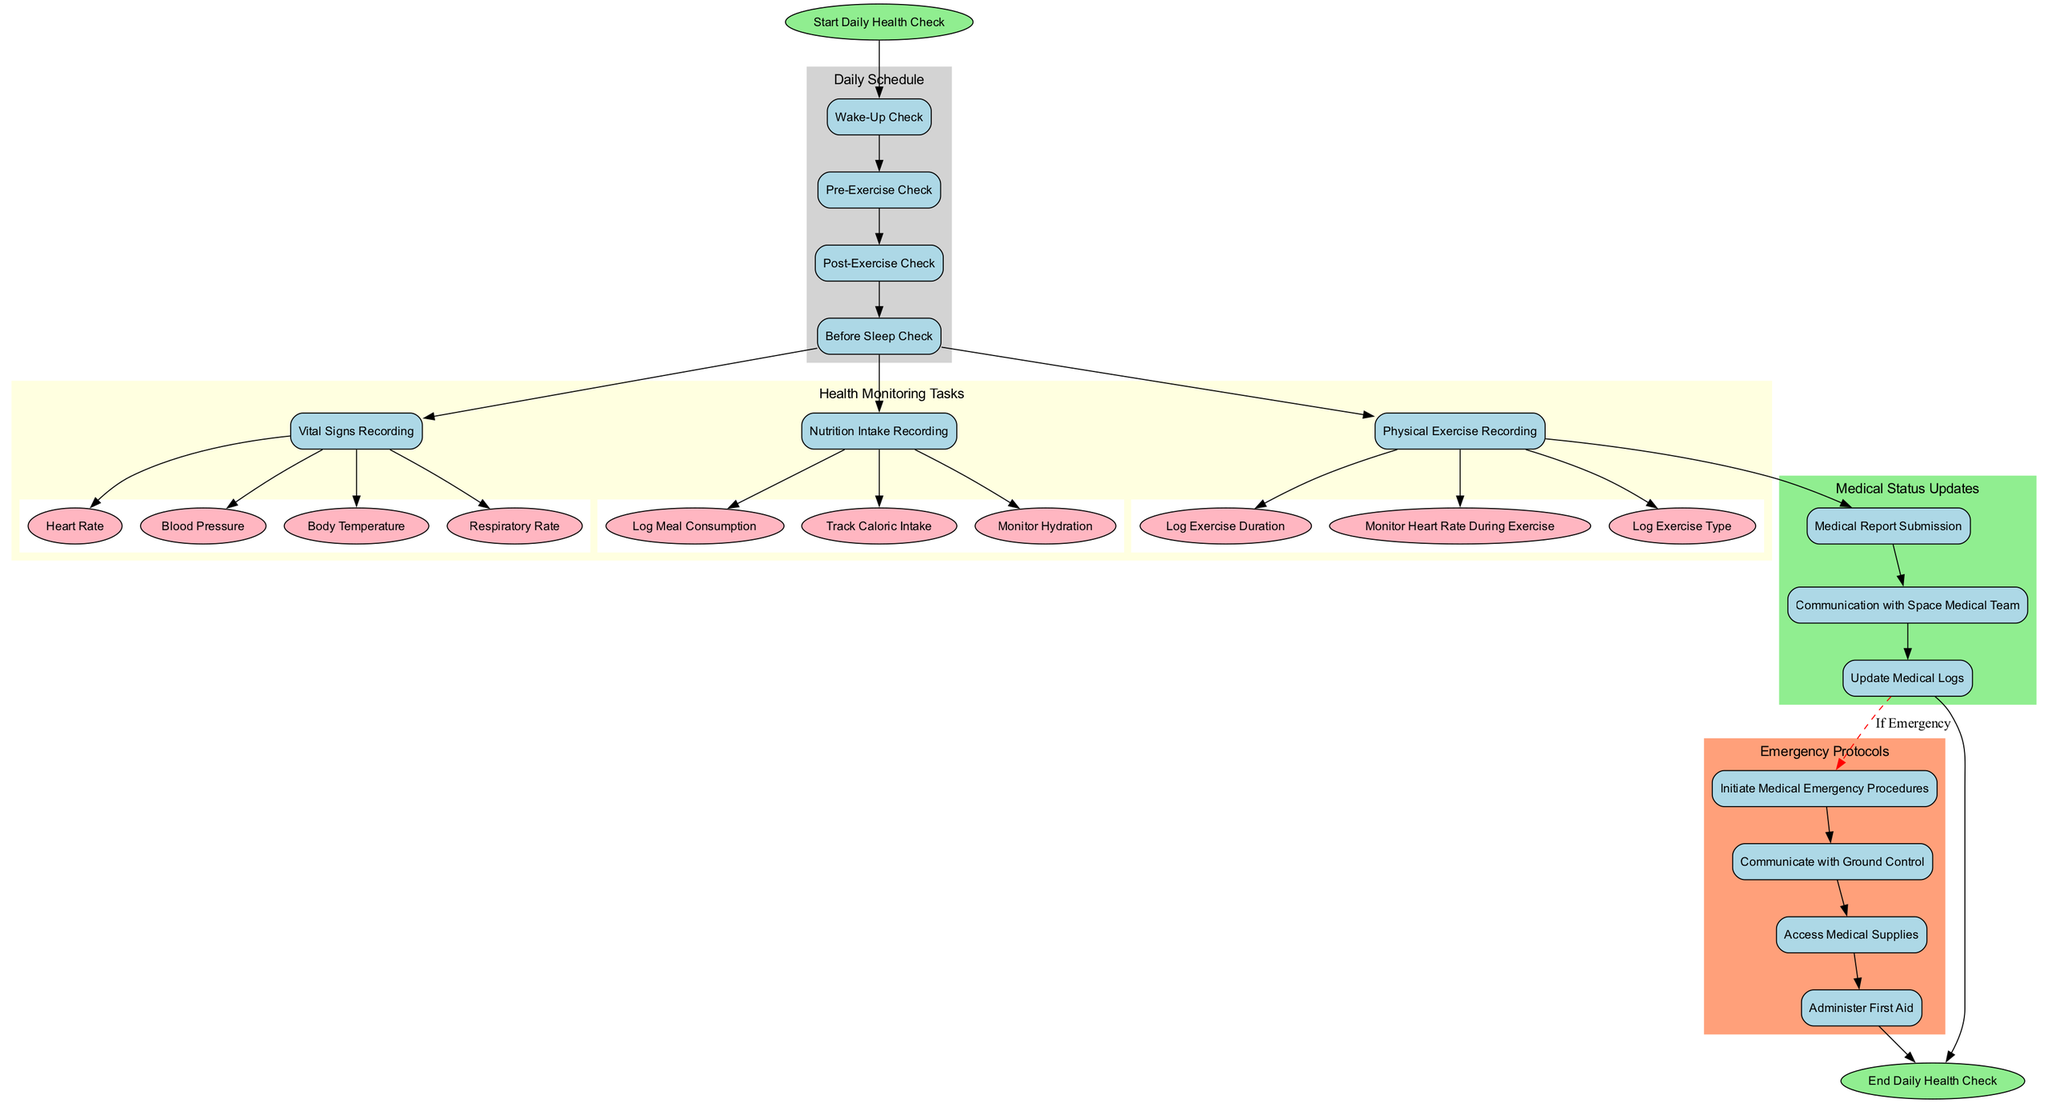What is the first daily health check in the schedule? The diagram indicates that the first daily health check is "Wake-Up Check", which is the first node in the Daily Schedule subgraph.
Answer: Wake-Up Check How many health monitoring tasks are listed in the diagram? Counting the nodes under "Health Monitoring Tasks", there are three main tasks: "Vital Signs Recording", "Nutrition Intake Recording", and "Physical Exercise Recording", making a total of 3.
Answer: 3 Which task follows "Post-Exercise Check" in the daily schedule? The diagram shows "Before Sleep Check" follows "Post-Exercise Check", indicating the sequential flow of tasks.
Answer: Before Sleep Check What is the last medical status update task listed? The final task under "Medical Status Updates" is "Update Medical Logs", which is the last node in that subgraph.
Answer: Update Medical Logs How many parameters are recorded in the "Vital Signs Recording" task? Listing the parameters shown in the "Vital Signs Recording", there are four parameters: "Heart Rate", "Blood Pressure", "Body Temperature", and "Respiratory Rate", which sums up to 4.
Answer: 4 What does the diagram indicate happens if a medical emergency is identified? The diagram indicates that if an emergency occurs, it activates the "Emergency Protocols" starting from "Medical Report Submission", leading to the relevant tasks under emergencies.
Answer: Initiate Medical Emergency Procedures Which instruments are used to check blood pressure during health monitoring? Among the listed instruments for "Vital Signs Recording", the "Blood Pressure Cuff" is specifically used to check blood pressure.
Answer: Blood Pressure Cuff What is the color of the "Emergency Protocols" cluster in the diagram? The "Emergency Protocols" cluster is colored "lightsalmon", clearly shown in the diagram that visually denotes this section.
Answer: lightsalmon How does the flowchart connect the health monitoring tasks to medical updates? The flowchart connects "Physical Exercise Recording" to "Medical Report Submission" with a direct edge, indicating the relationship between completing health monitoring and updating medical status.
Answer: Direct edge from Physical Exercise Recording to Medical Report Submission 